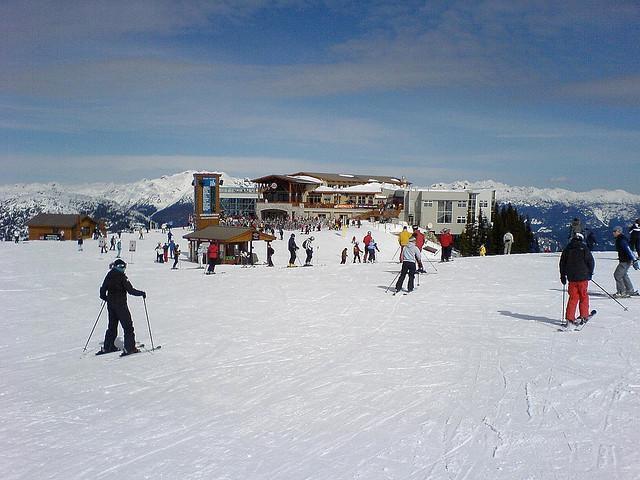How many people are in the picture?
Give a very brief answer. 3. 